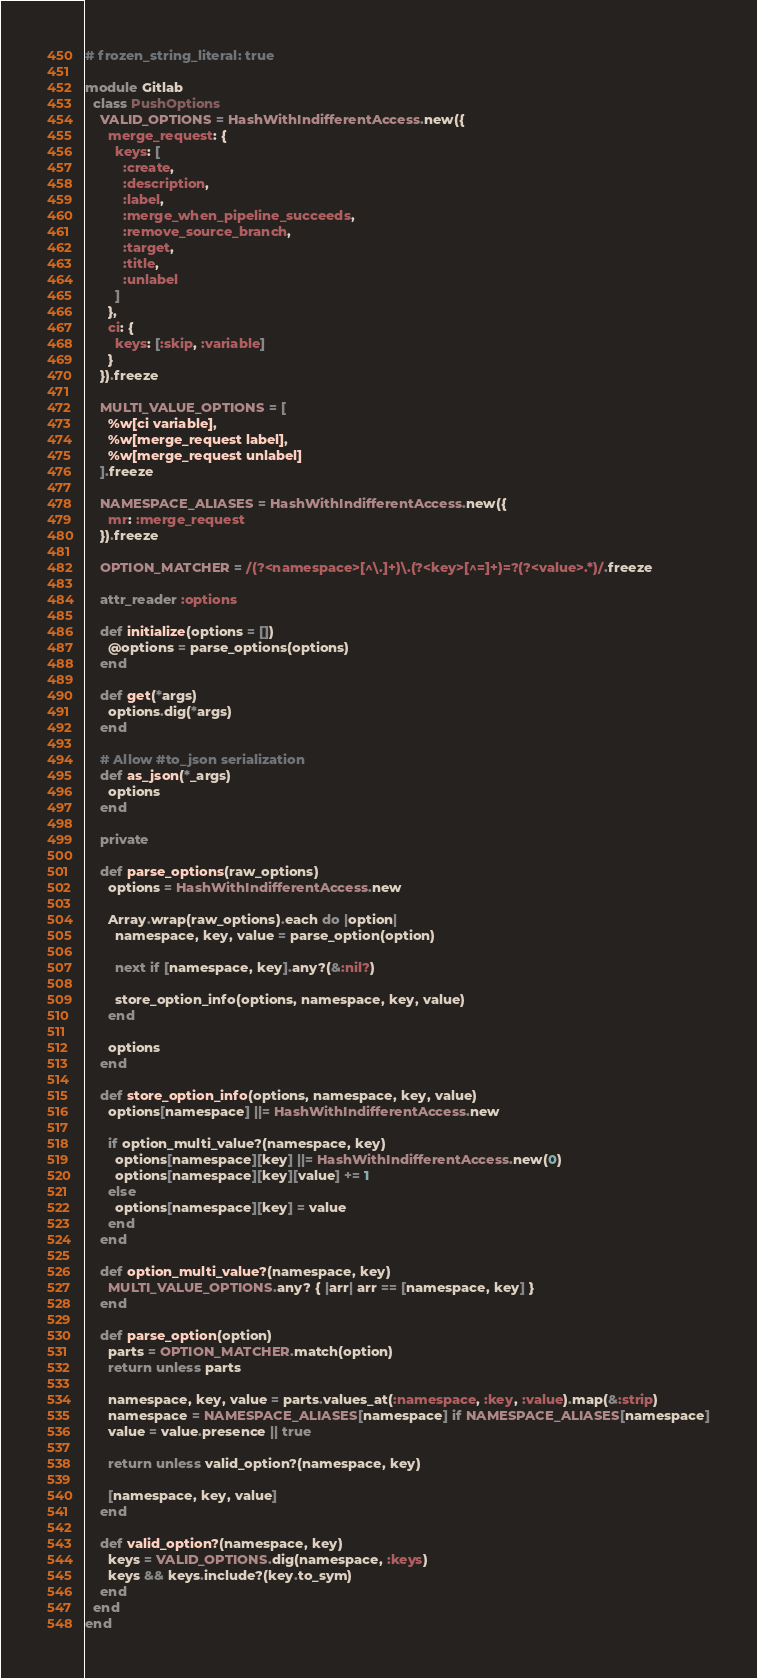<code> <loc_0><loc_0><loc_500><loc_500><_Ruby_># frozen_string_literal: true

module Gitlab
  class PushOptions
    VALID_OPTIONS = HashWithIndifferentAccess.new({
      merge_request: {
        keys: [
          :create,
          :description,
          :label,
          :merge_when_pipeline_succeeds,
          :remove_source_branch,
          :target,
          :title,
          :unlabel
        ]
      },
      ci: {
        keys: [:skip, :variable]
      }
    }).freeze

    MULTI_VALUE_OPTIONS = [
      %w[ci variable],
      %w[merge_request label],
      %w[merge_request unlabel]
    ].freeze

    NAMESPACE_ALIASES = HashWithIndifferentAccess.new({
      mr: :merge_request
    }).freeze

    OPTION_MATCHER = /(?<namespace>[^\.]+)\.(?<key>[^=]+)=?(?<value>.*)/.freeze

    attr_reader :options

    def initialize(options = [])
      @options = parse_options(options)
    end

    def get(*args)
      options.dig(*args)
    end

    # Allow #to_json serialization
    def as_json(*_args)
      options
    end

    private

    def parse_options(raw_options)
      options = HashWithIndifferentAccess.new

      Array.wrap(raw_options).each do |option|
        namespace, key, value = parse_option(option)

        next if [namespace, key].any?(&:nil?)

        store_option_info(options, namespace, key, value)
      end

      options
    end

    def store_option_info(options, namespace, key, value)
      options[namespace] ||= HashWithIndifferentAccess.new

      if option_multi_value?(namespace, key)
        options[namespace][key] ||= HashWithIndifferentAccess.new(0)
        options[namespace][key][value] += 1
      else
        options[namespace][key] = value
      end
    end

    def option_multi_value?(namespace, key)
      MULTI_VALUE_OPTIONS.any? { |arr| arr == [namespace, key] }
    end

    def parse_option(option)
      parts = OPTION_MATCHER.match(option)
      return unless parts

      namespace, key, value = parts.values_at(:namespace, :key, :value).map(&:strip)
      namespace = NAMESPACE_ALIASES[namespace] if NAMESPACE_ALIASES[namespace]
      value = value.presence || true

      return unless valid_option?(namespace, key)

      [namespace, key, value]
    end

    def valid_option?(namespace, key)
      keys = VALID_OPTIONS.dig(namespace, :keys)
      keys && keys.include?(key.to_sym)
    end
  end
end
</code> 